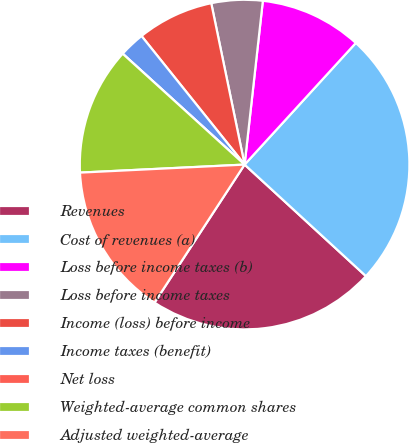Convert chart to OTSL. <chart><loc_0><loc_0><loc_500><loc_500><pie_chart><fcel>Revenues<fcel>Cost of revenues (a)<fcel>Loss before income taxes (b)<fcel>Loss before income taxes<fcel>Income (loss) before income<fcel>Income taxes (benefit)<fcel>Net loss<fcel>Weighted-average common shares<fcel>Adjusted weighted-average<nl><fcel>22.37%<fcel>25.04%<fcel>10.02%<fcel>5.01%<fcel>7.51%<fcel>2.5%<fcel>0.0%<fcel>12.52%<fcel>15.02%<nl></chart> 